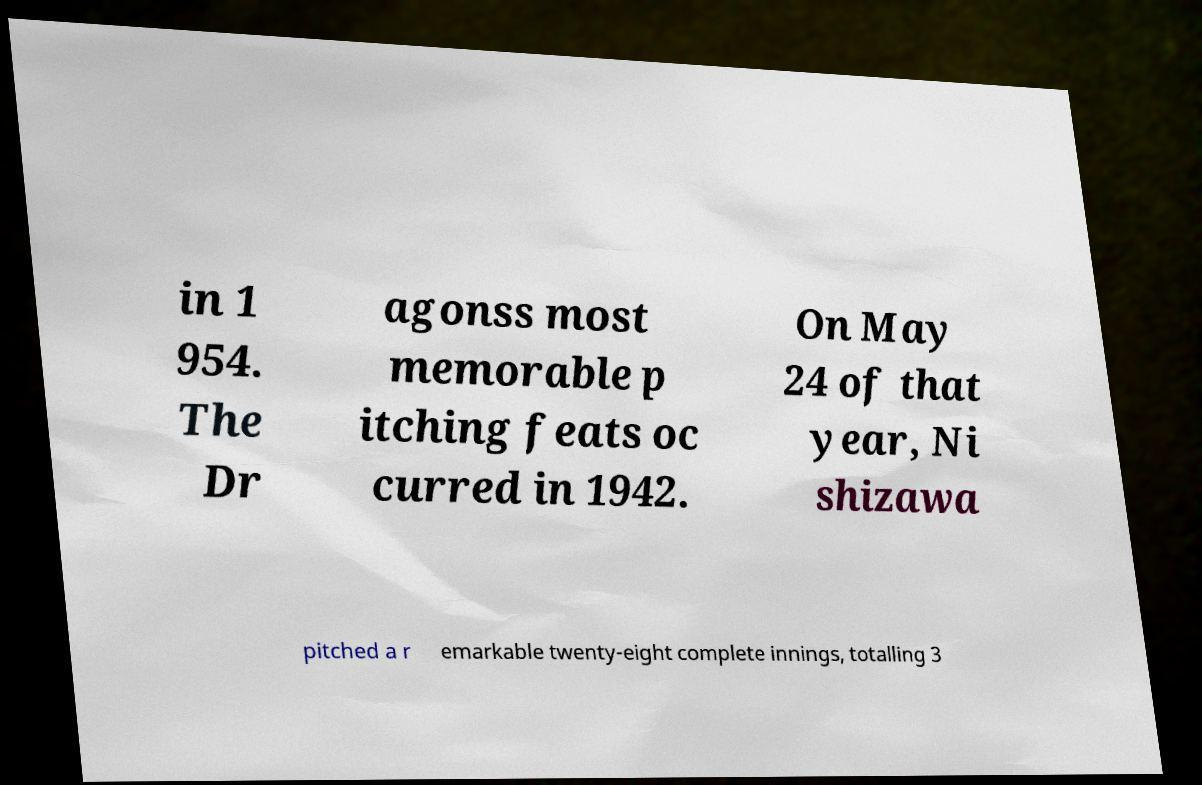Could you extract and type out the text from this image? in 1 954. The Dr agonss most memorable p itching feats oc curred in 1942. On May 24 of that year, Ni shizawa pitched a r emarkable twenty-eight complete innings, totalling 3 